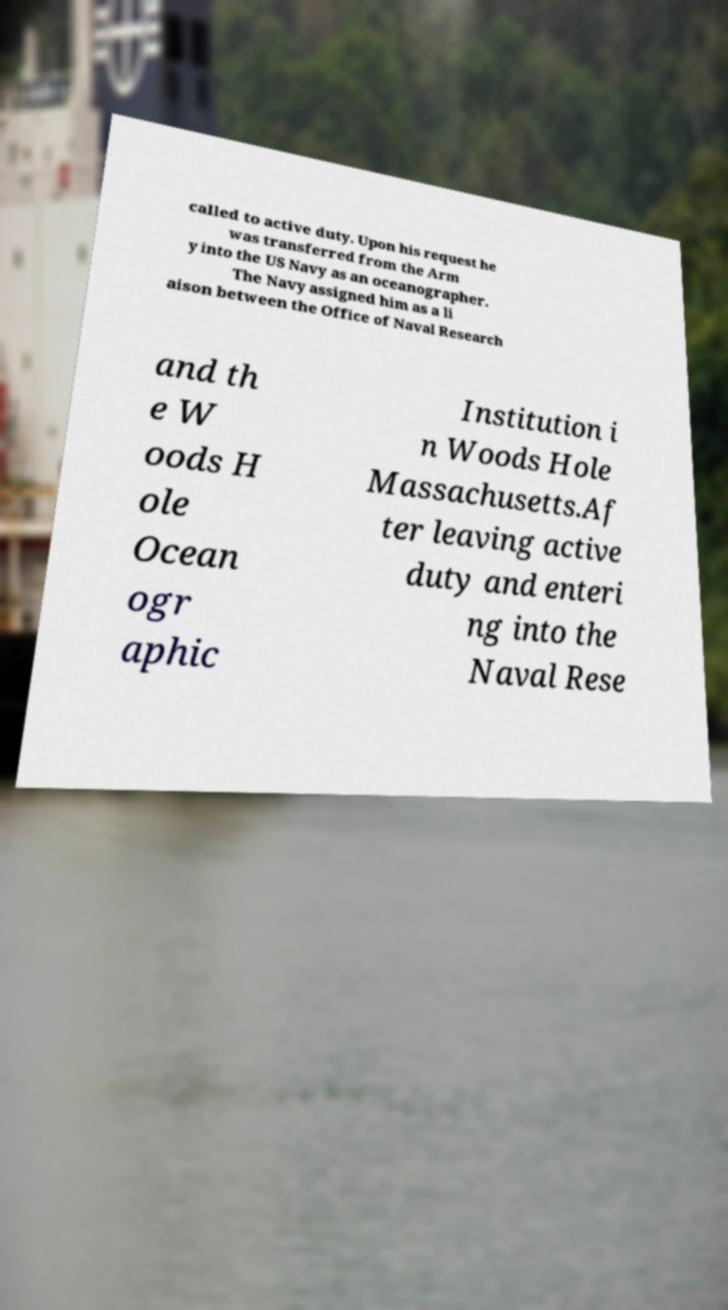What messages or text are displayed in this image? I need them in a readable, typed format. called to active duty. Upon his request he was transferred from the Arm y into the US Navy as an oceanographer. The Navy assigned him as a li aison between the Office of Naval Research and th e W oods H ole Ocean ogr aphic Institution i n Woods Hole Massachusetts.Af ter leaving active duty and enteri ng into the Naval Rese 